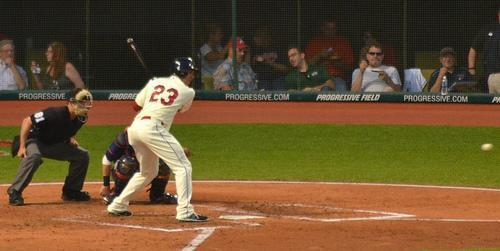How many batters are visible?
Give a very brief answer. 1. 